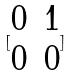<formula> <loc_0><loc_0><loc_500><loc_500>[ \begin{matrix} 0 & 1 \\ 0 & 0 \end{matrix} ]</formula> 